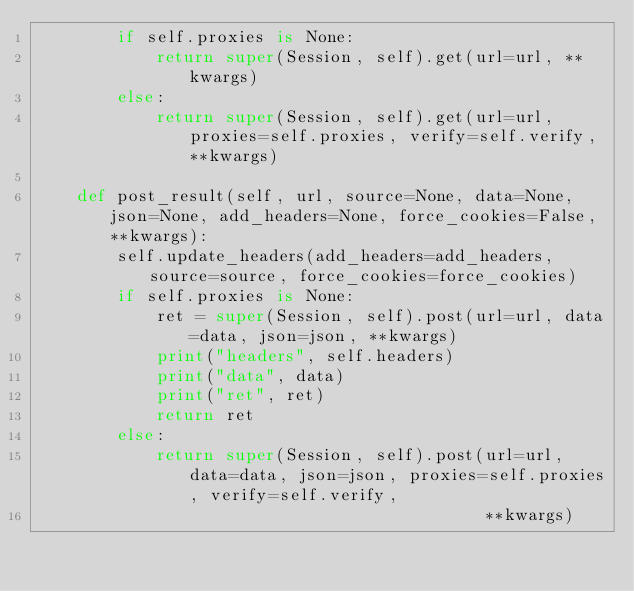Convert code to text. <code><loc_0><loc_0><loc_500><loc_500><_Python_>        if self.proxies is None:
            return super(Session, self).get(url=url, **kwargs)
        else:
            return super(Session, self).get(url=url, proxies=self.proxies, verify=self.verify, **kwargs)

    def post_result(self, url, source=None, data=None, json=None, add_headers=None, force_cookies=False, **kwargs):
        self.update_headers(add_headers=add_headers, source=source, force_cookies=force_cookies)
        if self.proxies is None:
            ret = super(Session, self).post(url=url, data=data, json=json, **kwargs)
            print("headers", self.headers)
            print("data", data)
            print("ret", ret)
            return ret
        else:
            return super(Session, self).post(url=url, data=data, json=json, proxies=self.proxies, verify=self.verify,
                                             **kwargs)
</code> 